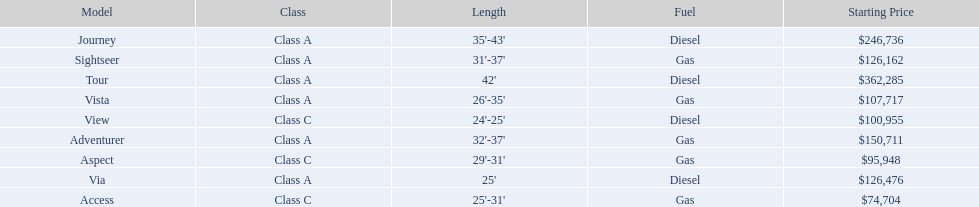What models are available from winnebago industries? Tour, Journey, Adventurer, Via, Sightseer, Vista, View, Aspect, Access. What are their starting prices? $362,285, $246,736, $150,711, $126,476, $126,162, $107,717, $100,955, $95,948, $74,704. Which model has the most costly starting price? Tour. 